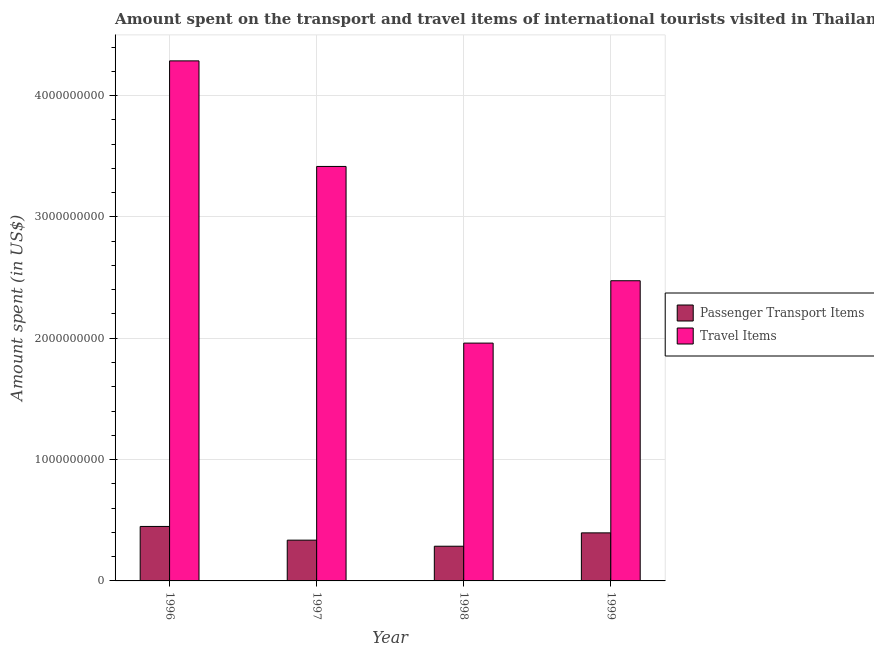How many groups of bars are there?
Your answer should be compact. 4. Are the number of bars on each tick of the X-axis equal?
Provide a short and direct response. Yes. How many bars are there on the 2nd tick from the right?
Offer a terse response. 2. What is the label of the 4th group of bars from the left?
Ensure brevity in your answer.  1999. In how many cases, is the number of bars for a given year not equal to the number of legend labels?
Offer a terse response. 0. What is the amount spent in travel items in 1997?
Give a very brief answer. 3.42e+09. Across all years, what is the maximum amount spent in travel items?
Keep it short and to the point. 4.29e+09. Across all years, what is the minimum amount spent on passenger transport items?
Your answer should be compact. 2.86e+08. In which year was the amount spent in travel items maximum?
Your answer should be very brief. 1996. What is the total amount spent in travel items in the graph?
Offer a very short reply. 1.21e+1. What is the difference between the amount spent on passenger transport items in 1996 and that in 1998?
Provide a succinct answer. 1.63e+08. What is the difference between the amount spent on passenger transport items in 1997 and the amount spent in travel items in 1998?
Provide a succinct answer. 5.00e+07. What is the average amount spent on passenger transport items per year?
Provide a succinct answer. 3.67e+08. What is the ratio of the amount spent on passenger transport items in 1997 to that in 1998?
Ensure brevity in your answer.  1.17. Is the amount spent in travel items in 1996 less than that in 1997?
Provide a succinct answer. No. What is the difference between the highest and the second highest amount spent on passenger transport items?
Provide a succinct answer. 5.30e+07. What is the difference between the highest and the lowest amount spent in travel items?
Keep it short and to the point. 2.33e+09. Is the sum of the amount spent on passenger transport items in 1996 and 1997 greater than the maximum amount spent in travel items across all years?
Your answer should be very brief. Yes. What does the 2nd bar from the left in 1999 represents?
Make the answer very short. Travel Items. What does the 2nd bar from the right in 1999 represents?
Your answer should be compact. Passenger Transport Items. Are all the bars in the graph horizontal?
Offer a very short reply. No. What is the difference between two consecutive major ticks on the Y-axis?
Make the answer very short. 1.00e+09. Are the values on the major ticks of Y-axis written in scientific E-notation?
Your answer should be very brief. No. Does the graph contain any zero values?
Your answer should be compact. No. How many legend labels are there?
Ensure brevity in your answer.  2. How are the legend labels stacked?
Your answer should be very brief. Vertical. What is the title of the graph?
Your response must be concise. Amount spent on the transport and travel items of international tourists visited in Thailand. Does "Research and Development" appear as one of the legend labels in the graph?
Ensure brevity in your answer.  No. What is the label or title of the Y-axis?
Make the answer very short. Amount spent (in US$). What is the Amount spent (in US$) in Passenger Transport Items in 1996?
Your answer should be very brief. 4.49e+08. What is the Amount spent (in US$) in Travel Items in 1996?
Keep it short and to the point. 4.29e+09. What is the Amount spent (in US$) in Passenger Transport Items in 1997?
Your answer should be very brief. 3.36e+08. What is the Amount spent (in US$) of Travel Items in 1997?
Offer a terse response. 3.42e+09. What is the Amount spent (in US$) of Passenger Transport Items in 1998?
Your answer should be compact. 2.86e+08. What is the Amount spent (in US$) of Travel Items in 1998?
Offer a terse response. 1.96e+09. What is the Amount spent (in US$) in Passenger Transport Items in 1999?
Your answer should be compact. 3.96e+08. What is the Amount spent (in US$) in Travel Items in 1999?
Offer a terse response. 2.47e+09. Across all years, what is the maximum Amount spent (in US$) in Passenger Transport Items?
Ensure brevity in your answer.  4.49e+08. Across all years, what is the maximum Amount spent (in US$) in Travel Items?
Give a very brief answer. 4.29e+09. Across all years, what is the minimum Amount spent (in US$) in Passenger Transport Items?
Provide a succinct answer. 2.86e+08. Across all years, what is the minimum Amount spent (in US$) in Travel Items?
Offer a very short reply. 1.96e+09. What is the total Amount spent (in US$) of Passenger Transport Items in the graph?
Provide a succinct answer. 1.47e+09. What is the total Amount spent (in US$) in Travel Items in the graph?
Provide a short and direct response. 1.21e+1. What is the difference between the Amount spent (in US$) of Passenger Transport Items in 1996 and that in 1997?
Your answer should be very brief. 1.13e+08. What is the difference between the Amount spent (in US$) of Travel Items in 1996 and that in 1997?
Your response must be concise. 8.70e+08. What is the difference between the Amount spent (in US$) in Passenger Transport Items in 1996 and that in 1998?
Offer a terse response. 1.63e+08. What is the difference between the Amount spent (in US$) of Travel Items in 1996 and that in 1998?
Keep it short and to the point. 2.33e+09. What is the difference between the Amount spent (in US$) of Passenger Transport Items in 1996 and that in 1999?
Your answer should be compact. 5.30e+07. What is the difference between the Amount spent (in US$) of Travel Items in 1996 and that in 1999?
Keep it short and to the point. 1.81e+09. What is the difference between the Amount spent (in US$) of Passenger Transport Items in 1997 and that in 1998?
Offer a terse response. 5.00e+07. What is the difference between the Amount spent (in US$) of Travel Items in 1997 and that in 1998?
Make the answer very short. 1.46e+09. What is the difference between the Amount spent (in US$) of Passenger Transport Items in 1997 and that in 1999?
Keep it short and to the point. -6.00e+07. What is the difference between the Amount spent (in US$) of Travel Items in 1997 and that in 1999?
Give a very brief answer. 9.42e+08. What is the difference between the Amount spent (in US$) of Passenger Transport Items in 1998 and that in 1999?
Offer a terse response. -1.10e+08. What is the difference between the Amount spent (in US$) in Travel Items in 1998 and that in 1999?
Keep it short and to the point. -5.14e+08. What is the difference between the Amount spent (in US$) in Passenger Transport Items in 1996 and the Amount spent (in US$) in Travel Items in 1997?
Provide a succinct answer. -2.97e+09. What is the difference between the Amount spent (in US$) in Passenger Transport Items in 1996 and the Amount spent (in US$) in Travel Items in 1998?
Give a very brief answer. -1.51e+09. What is the difference between the Amount spent (in US$) in Passenger Transport Items in 1996 and the Amount spent (in US$) in Travel Items in 1999?
Make the answer very short. -2.02e+09. What is the difference between the Amount spent (in US$) of Passenger Transport Items in 1997 and the Amount spent (in US$) of Travel Items in 1998?
Your answer should be very brief. -1.62e+09. What is the difference between the Amount spent (in US$) in Passenger Transport Items in 1997 and the Amount spent (in US$) in Travel Items in 1999?
Offer a terse response. -2.14e+09. What is the difference between the Amount spent (in US$) of Passenger Transport Items in 1998 and the Amount spent (in US$) of Travel Items in 1999?
Keep it short and to the point. -2.19e+09. What is the average Amount spent (in US$) of Passenger Transport Items per year?
Give a very brief answer. 3.67e+08. What is the average Amount spent (in US$) in Travel Items per year?
Provide a succinct answer. 3.03e+09. In the year 1996, what is the difference between the Amount spent (in US$) in Passenger Transport Items and Amount spent (in US$) in Travel Items?
Offer a very short reply. -3.84e+09. In the year 1997, what is the difference between the Amount spent (in US$) of Passenger Transport Items and Amount spent (in US$) of Travel Items?
Offer a very short reply. -3.08e+09. In the year 1998, what is the difference between the Amount spent (in US$) in Passenger Transport Items and Amount spent (in US$) in Travel Items?
Offer a very short reply. -1.67e+09. In the year 1999, what is the difference between the Amount spent (in US$) in Passenger Transport Items and Amount spent (in US$) in Travel Items?
Provide a succinct answer. -2.08e+09. What is the ratio of the Amount spent (in US$) in Passenger Transport Items in 1996 to that in 1997?
Provide a succinct answer. 1.34. What is the ratio of the Amount spent (in US$) of Travel Items in 1996 to that in 1997?
Ensure brevity in your answer.  1.25. What is the ratio of the Amount spent (in US$) of Passenger Transport Items in 1996 to that in 1998?
Your answer should be very brief. 1.57. What is the ratio of the Amount spent (in US$) in Travel Items in 1996 to that in 1998?
Offer a very short reply. 2.19. What is the ratio of the Amount spent (in US$) of Passenger Transport Items in 1996 to that in 1999?
Offer a terse response. 1.13. What is the ratio of the Amount spent (in US$) of Travel Items in 1996 to that in 1999?
Your answer should be compact. 1.73. What is the ratio of the Amount spent (in US$) of Passenger Transport Items in 1997 to that in 1998?
Give a very brief answer. 1.17. What is the ratio of the Amount spent (in US$) of Travel Items in 1997 to that in 1998?
Keep it short and to the point. 1.74. What is the ratio of the Amount spent (in US$) in Passenger Transport Items in 1997 to that in 1999?
Your answer should be very brief. 0.85. What is the ratio of the Amount spent (in US$) of Travel Items in 1997 to that in 1999?
Make the answer very short. 1.38. What is the ratio of the Amount spent (in US$) of Passenger Transport Items in 1998 to that in 1999?
Ensure brevity in your answer.  0.72. What is the ratio of the Amount spent (in US$) of Travel Items in 1998 to that in 1999?
Your answer should be very brief. 0.79. What is the difference between the highest and the second highest Amount spent (in US$) of Passenger Transport Items?
Provide a succinct answer. 5.30e+07. What is the difference between the highest and the second highest Amount spent (in US$) of Travel Items?
Your answer should be compact. 8.70e+08. What is the difference between the highest and the lowest Amount spent (in US$) in Passenger Transport Items?
Your response must be concise. 1.63e+08. What is the difference between the highest and the lowest Amount spent (in US$) in Travel Items?
Keep it short and to the point. 2.33e+09. 